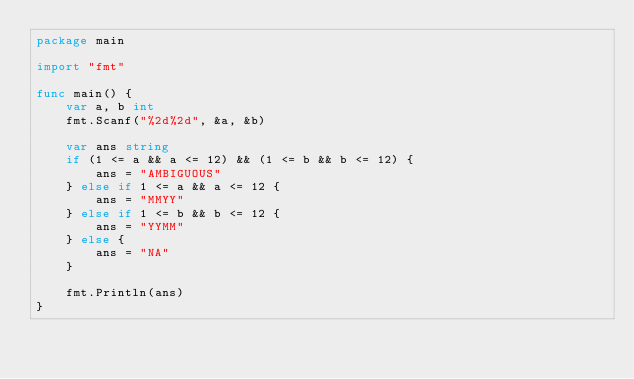Convert code to text. <code><loc_0><loc_0><loc_500><loc_500><_Go_>package main

import "fmt"

func main() {
	var a, b int
	fmt.Scanf("%2d%2d", &a, &b)

	var ans string
	if (1 <= a && a <= 12) && (1 <= b && b <= 12) {
		ans = "AMBIGUOUS"
	} else if 1 <= a && a <= 12 {
		ans = "MMYY"
	} else if 1 <= b && b <= 12 {
		ans = "YYMM"
	} else {
		ans = "NA"
	}

	fmt.Println(ans)
}
</code> 